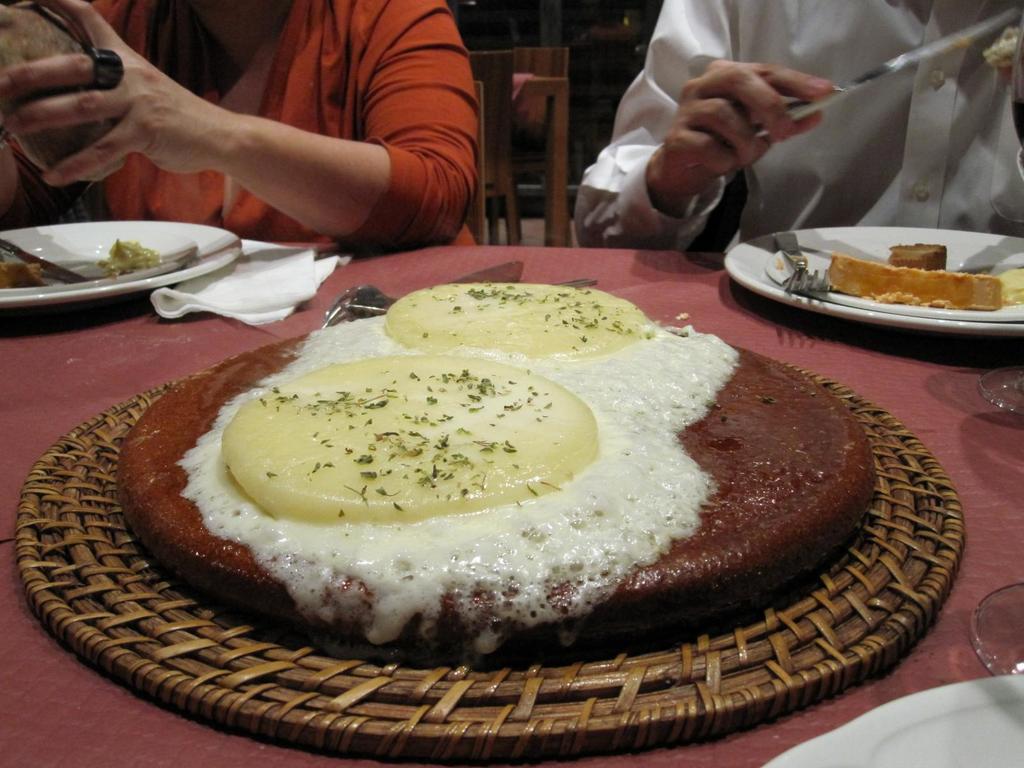Can you describe this image briefly? There are food items in the place, where there are two people. 